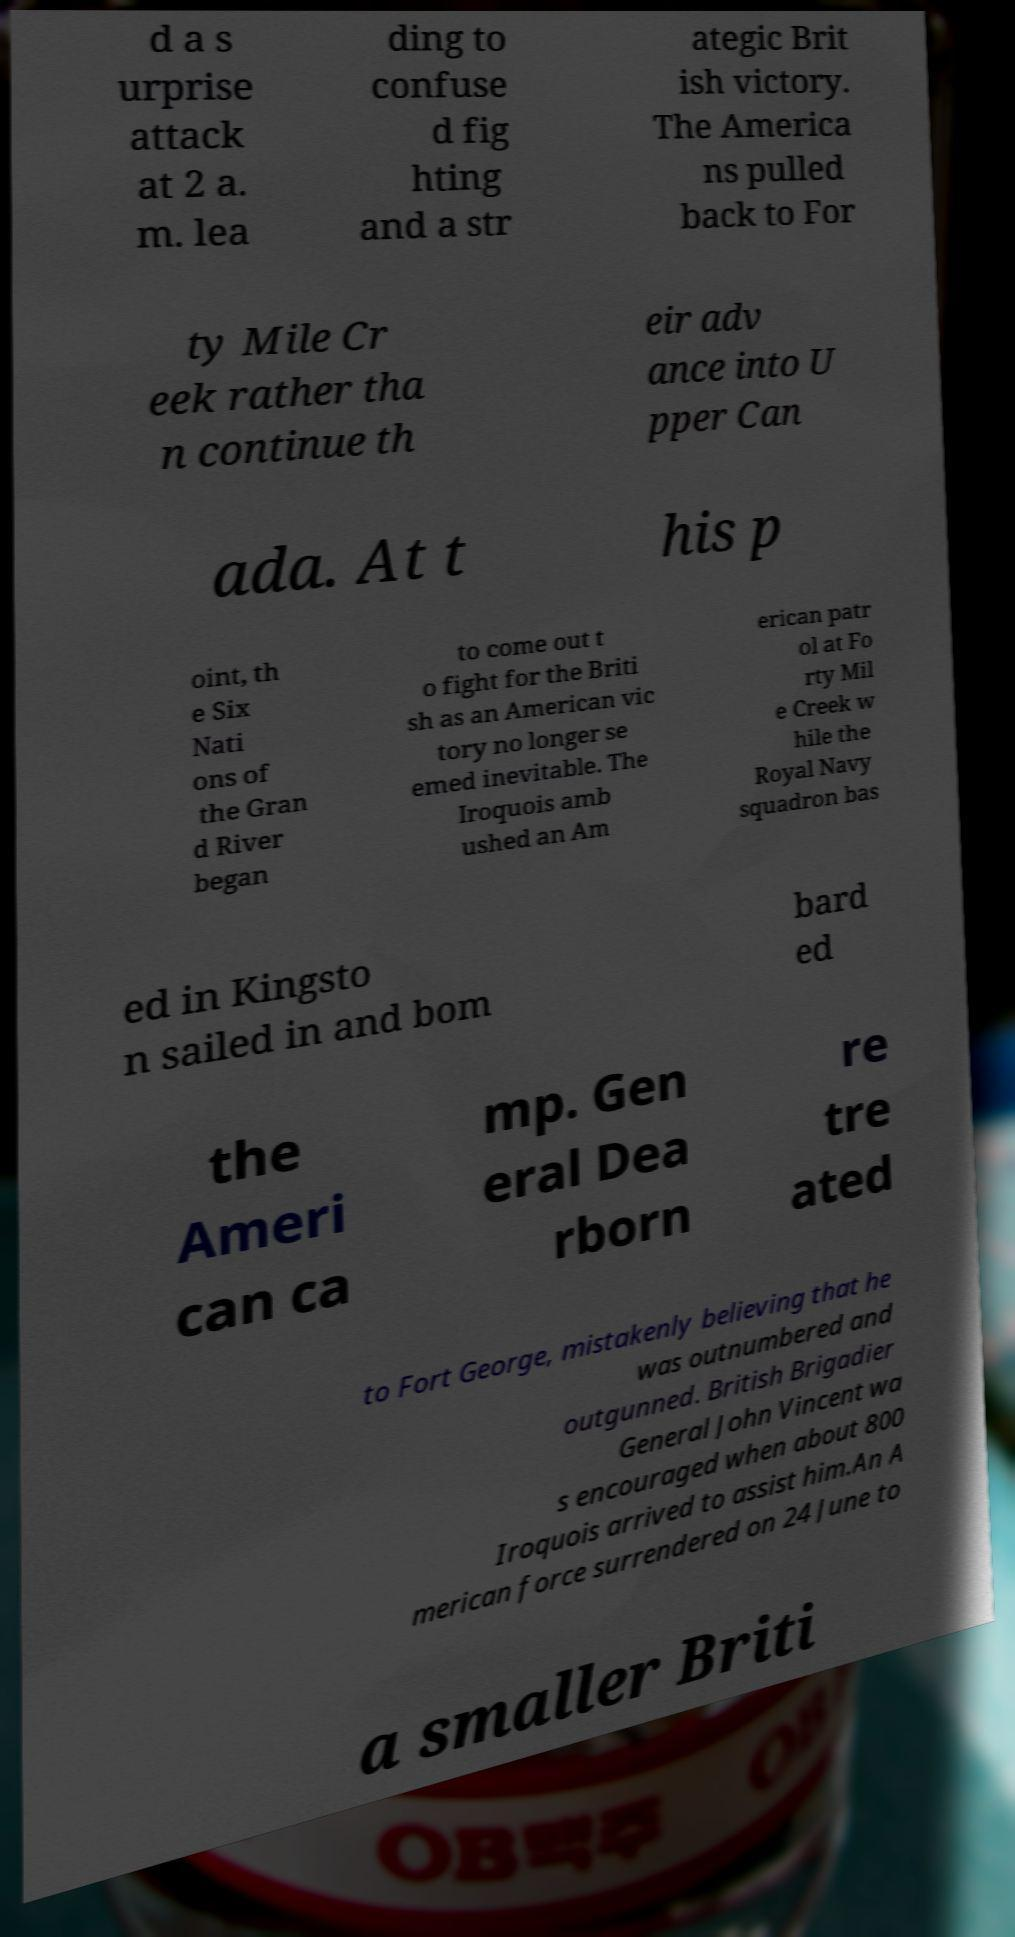Could you assist in decoding the text presented in this image and type it out clearly? d a s urprise attack at 2 a. m. lea ding to confuse d fig hting and a str ategic Brit ish victory. The America ns pulled back to For ty Mile Cr eek rather tha n continue th eir adv ance into U pper Can ada. At t his p oint, th e Six Nati ons of the Gran d River began to come out t o fight for the Briti sh as an American vic tory no longer se emed inevitable. The Iroquois amb ushed an Am erican patr ol at Fo rty Mil e Creek w hile the Royal Navy squadron bas ed in Kingsto n sailed in and bom bard ed the Ameri can ca mp. Gen eral Dea rborn re tre ated to Fort George, mistakenly believing that he was outnumbered and outgunned. British Brigadier General John Vincent wa s encouraged when about 800 Iroquois arrived to assist him.An A merican force surrendered on 24 June to a smaller Briti 